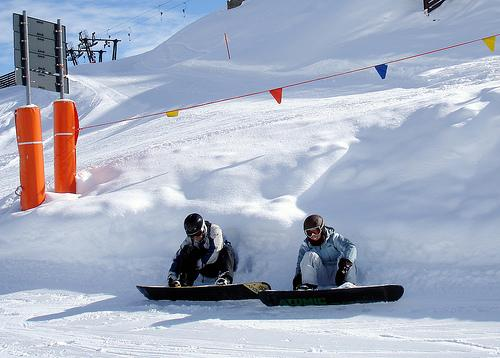Mention one activity the couple is doing while relaxing on the ski slope. The couple is sitting down and likely resting while they relax on the ski slope. What is one of the captions for the couple in snowboarding gear? A couple adjusting snowboards in groomed snow. What is the overall sentiment of the image involving snowboarders and the ski area? The image conveys a fun and adventurous sentiment, as it depicts snowboarders enjoying their time on a ski slope. Are the tracks in the snow in good condition, and what is the state of the ski lift? The tracks in the snow are well-groomed, and the ski lift appears to be functional, overlooking the hill. Count the number of flags in the image and list their colors. There are 6 flags in the image: 1 yellow, 1 red, 1 blue, 1 red triangle, 1 blue triangle, and 1 yellow triangle. Identify the color of the objects sticking out of the snow and describe their shape. The objects sticking out of the snow are orange and shaped like poles. How many snowboarders are there in the image, and what are they doing? There are two snowboarders present, and they are dismounting and adjusting their snowboards. Describe the scene in the ski area with focus on ropes and flags. There are ropes with yellow, green, and red flags all around the ski area, making a marked barrier on the groomed ski run. What is written on the snowboard that is black in color? The word "atomic" is written in green on the black snowboard. What are the snowboarders wearing on their heads and faces for protection? The snowboarders are wearing helmets on their heads and goggles with red lenses on their faces. 